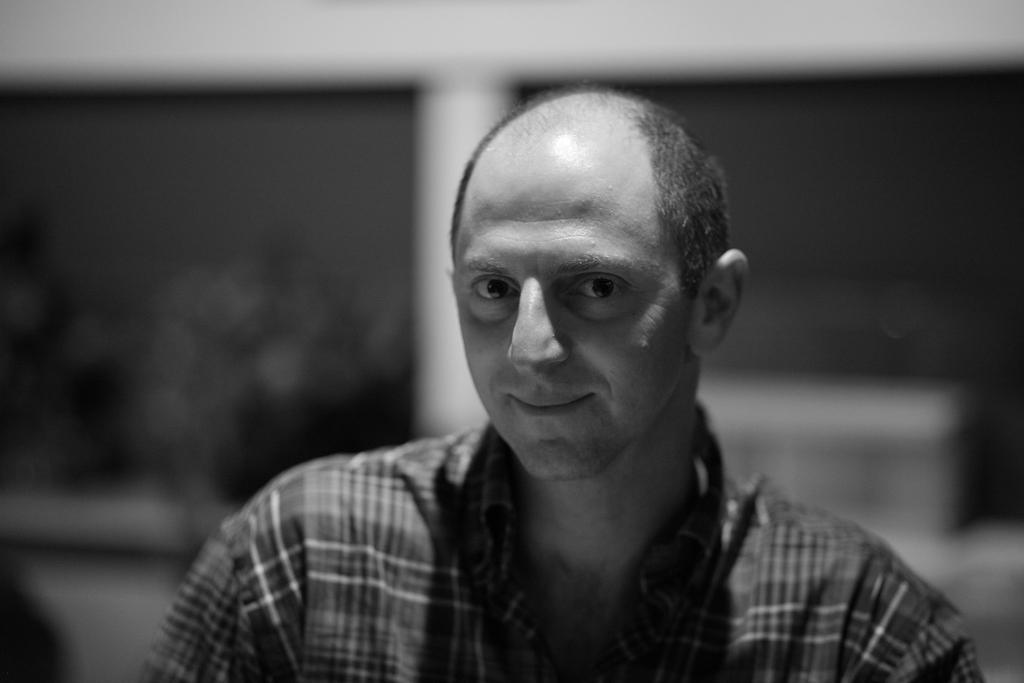What is the color scheme of the picture? The picture is black and white. Can you describe the person in the picture? There is a person in the picture, and they are smiling. What can be said about the background of the picture? The background of the picture is blurred. What type of oatmeal is the person eating in the picture? There is no oatmeal present in the picture, as it is a black and white image with a person smiling and a blurred background. 